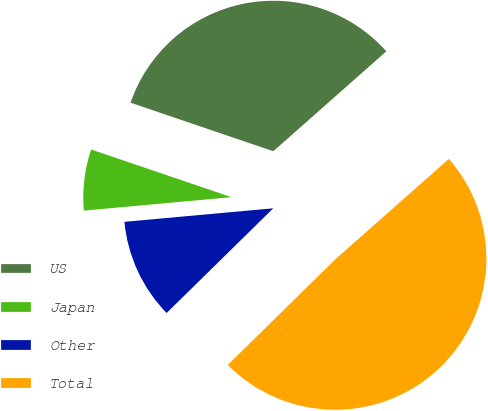Convert chart to OTSL. <chart><loc_0><loc_0><loc_500><loc_500><pie_chart><fcel>US<fcel>Japan<fcel>Other<fcel>Total<nl><fcel>33.26%<fcel>6.66%<fcel>10.91%<fcel>49.16%<nl></chart> 